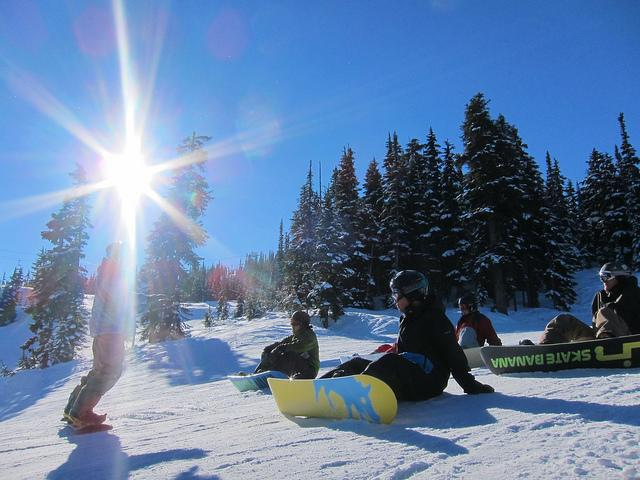Who is the man standing in front of the group?

Choices:
A) uncle
B) father
C) pastor
D) instructor instructor 